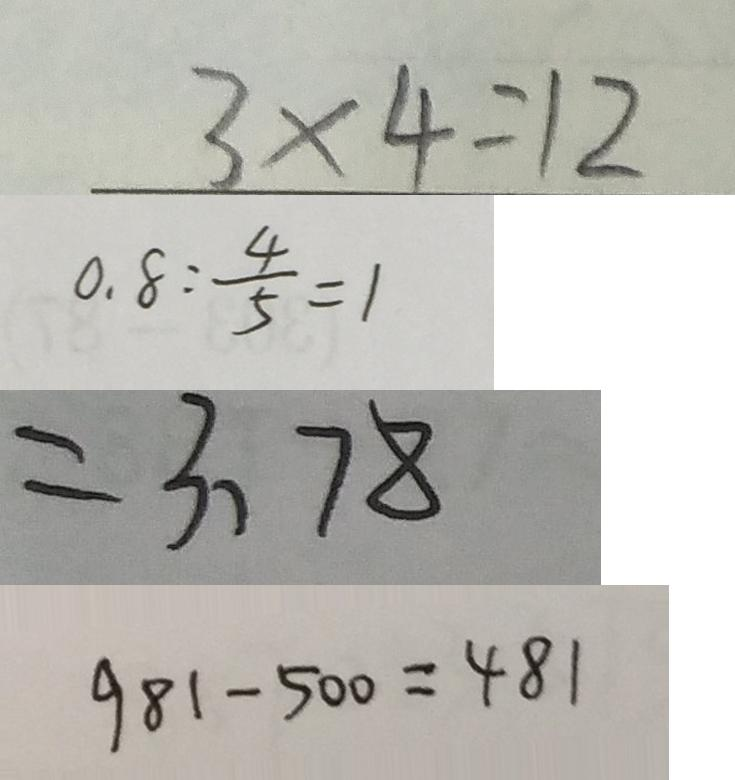Convert formula to latex. <formula><loc_0><loc_0><loc_500><loc_500>3 \times 4 = 1 2 
 0 . 8 : \frac { 4 } { 5 } = 1 
 = 3 、 7 8 
 9 8 1 - 5 0 0 = 4 8 1</formula> 